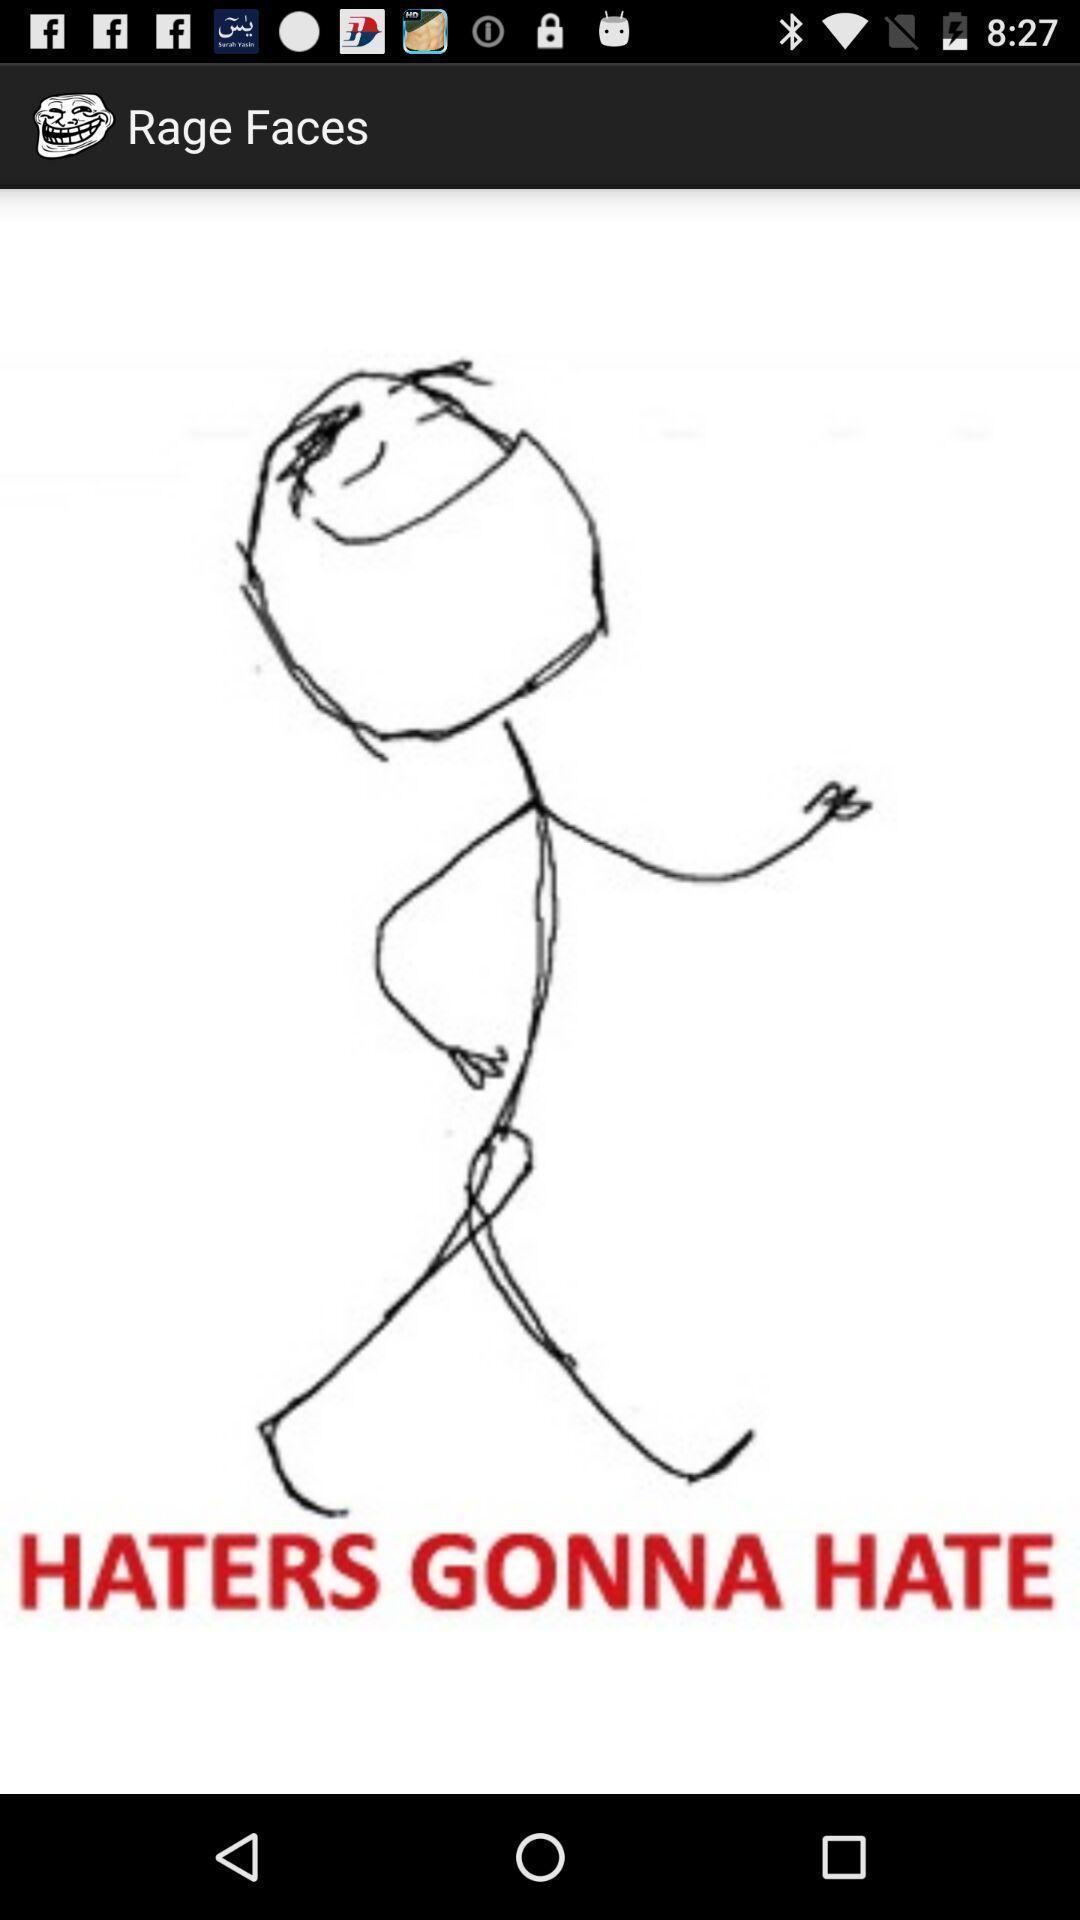Give me a summary of this screen capture. Screen showing sketch and quote. 